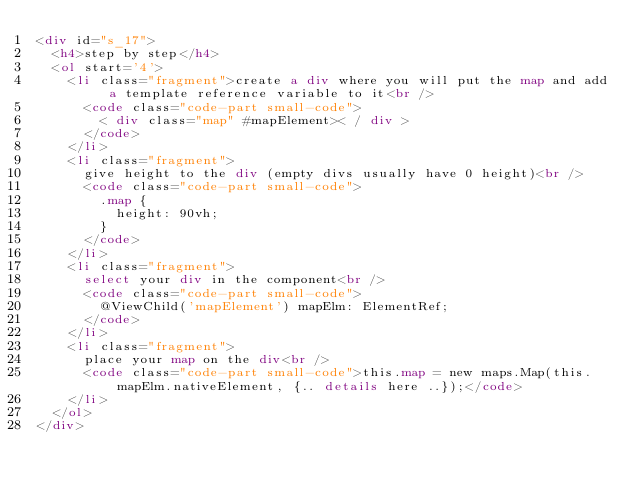<code> <loc_0><loc_0><loc_500><loc_500><_HTML_><div id="s_17">
	<h4>step by step</h4>
	<ol start='4'>
		<li class="fragment">create a div where you will put the map and add a template reference variable to it<br />
			<code class="code-part small-code">
				< div class="map" #mapElement>< / div >
			</code>
		</li>
		<li class="fragment">
			give height to the div (empty divs usually have 0 height)<br />
			<code class="code-part small-code">
				.map {
  				height: 90vh;
				}
			</code>
		</li>
		<li class="fragment">
			select your div in the component<br />
			<code class="code-part small-code">
				@ViewChild('mapElement') mapElm: ElementRef;
			</code>
		</li>
		<li class="fragment">
			place your map on the div<br />
			<code class="code-part small-code">this.map = new maps.Map(this.mapElm.nativeElement, {.. details here ..});</code>
		</li>
	</ol>
</div>
</code> 